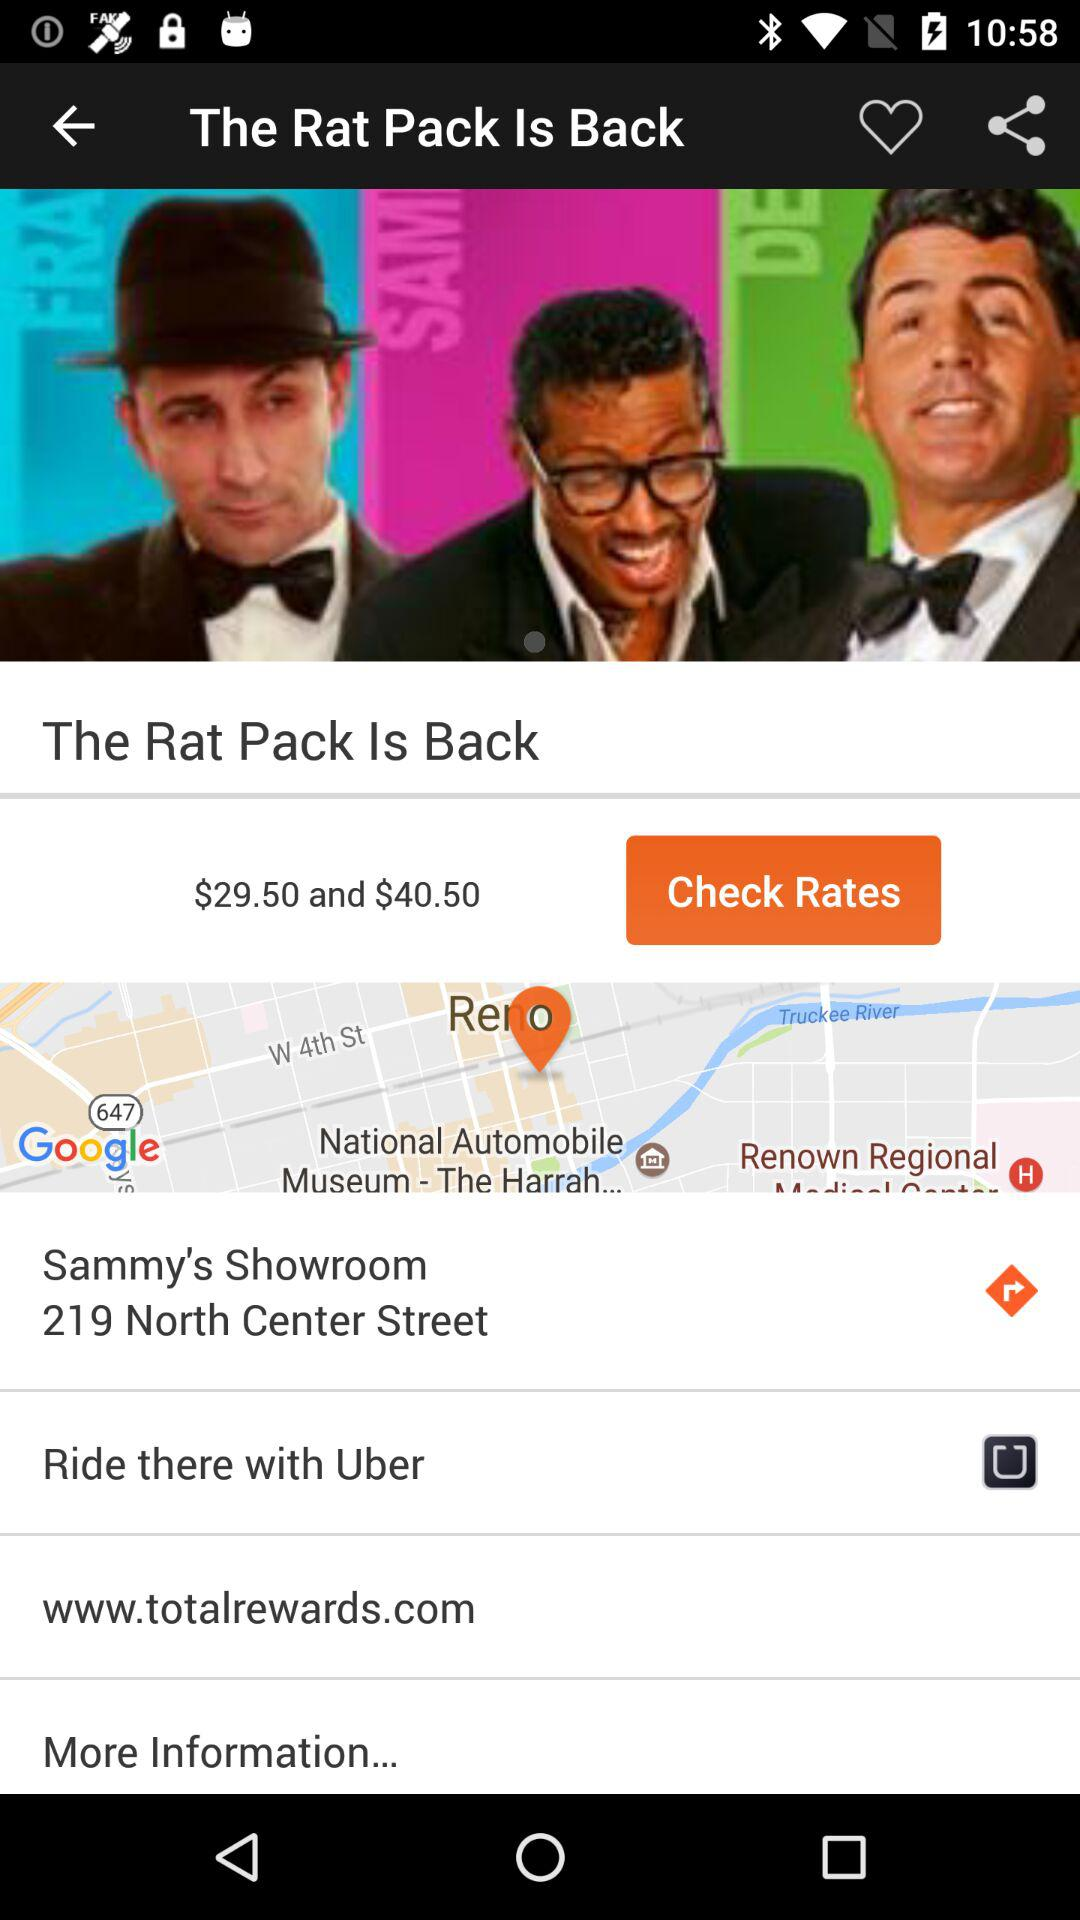What is the website? The website is www.totalrewards.com. 